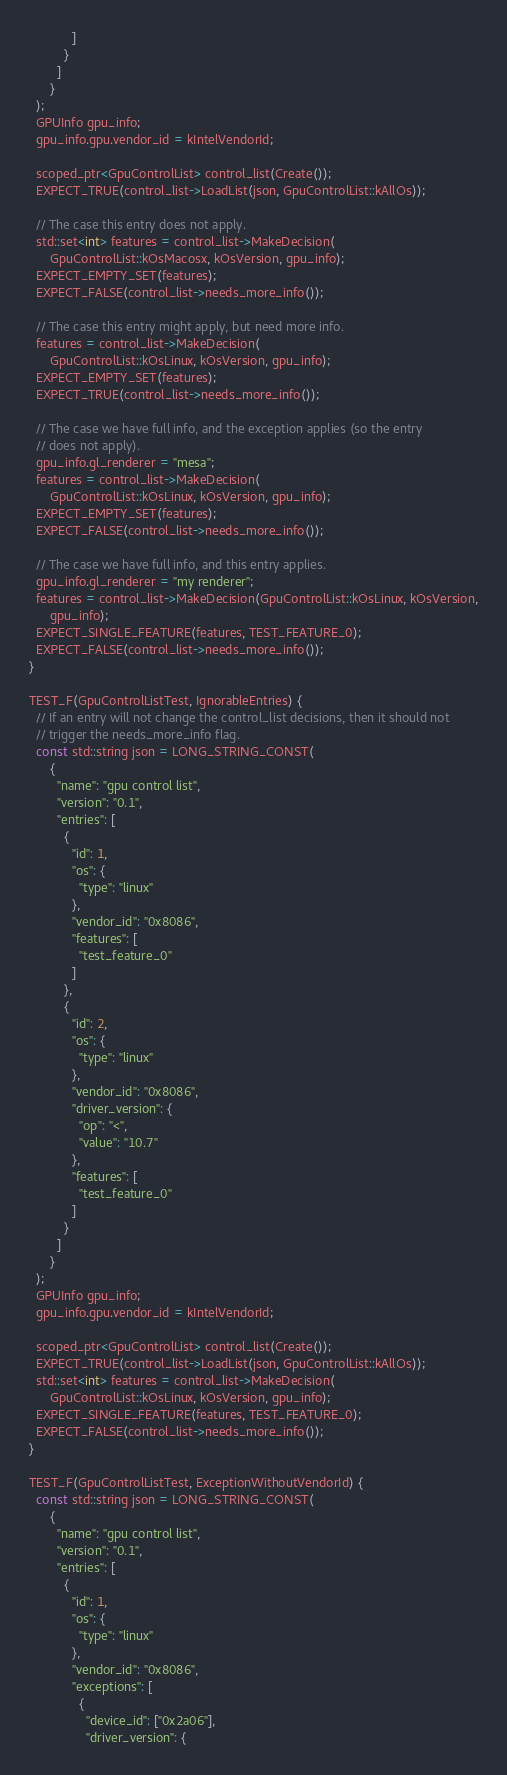<code> <loc_0><loc_0><loc_500><loc_500><_C++_>            ]
          }
        ]
      }
  );
  GPUInfo gpu_info;
  gpu_info.gpu.vendor_id = kIntelVendorId;

  scoped_ptr<GpuControlList> control_list(Create());
  EXPECT_TRUE(control_list->LoadList(json, GpuControlList::kAllOs));

  // The case this entry does not apply.
  std::set<int> features = control_list->MakeDecision(
      GpuControlList::kOsMacosx, kOsVersion, gpu_info);
  EXPECT_EMPTY_SET(features);
  EXPECT_FALSE(control_list->needs_more_info());

  // The case this entry might apply, but need more info.
  features = control_list->MakeDecision(
      GpuControlList::kOsLinux, kOsVersion, gpu_info);
  EXPECT_EMPTY_SET(features);
  EXPECT_TRUE(control_list->needs_more_info());

  // The case we have full info, and the exception applies (so the entry
  // does not apply).
  gpu_info.gl_renderer = "mesa";
  features = control_list->MakeDecision(
      GpuControlList::kOsLinux, kOsVersion, gpu_info);
  EXPECT_EMPTY_SET(features);
  EXPECT_FALSE(control_list->needs_more_info());

  // The case we have full info, and this entry applies.
  gpu_info.gl_renderer = "my renderer";
  features = control_list->MakeDecision(GpuControlList::kOsLinux, kOsVersion,
      gpu_info);
  EXPECT_SINGLE_FEATURE(features, TEST_FEATURE_0);
  EXPECT_FALSE(control_list->needs_more_info());
}

TEST_F(GpuControlListTest, IgnorableEntries) {
  // If an entry will not change the control_list decisions, then it should not
  // trigger the needs_more_info flag.
  const std::string json = LONG_STRING_CONST(
      {
        "name": "gpu control list",
        "version": "0.1",
        "entries": [
          {
            "id": 1,
            "os": {
              "type": "linux"
            },
            "vendor_id": "0x8086",
            "features": [
              "test_feature_0"
            ]
          },
          {
            "id": 2,
            "os": {
              "type": "linux"
            },
            "vendor_id": "0x8086",
            "driver_version": {
              "op": "<",
              "value": "10.7"
            },
            "features": [
              "test_feature_0"
            ]
          }
        ]
      }
  );
  GPUInfo gpu_info;
  gpu_info.gpu.vendor_id = kIntelVendorId;

  scoped_ptr<GpuControlList> control_list(Create());
  EXPECT_TRUE(control_list->LoadList(json, GpuControlList::kAllOs));
  std::set<int> features = control_list->MakeDecision(
      GpuControlList::kOsLinux, kOsVersion, gpu_info);
  EXPECT_SINGLE_FEATURE(features, TEST_FEATURE_0);
  EXPECT_FALSE(control_list->needs_more_info());
}

TEST_F(GpuControlListTest, ExceptionWithoutVendorId) {
  const std::string json = LONG_STRING_CONST(
      {
        "name": "gpu control list",
        "version": "0.1",
        "entries": [
          {
            "id": 1,
            "os": {
              "type": "linux"
            },
            "vendor_id": "0x8086",
            "exceptions": [
              {
                "device_id": ["0x2a06"],
                "driver_version": {</code> 